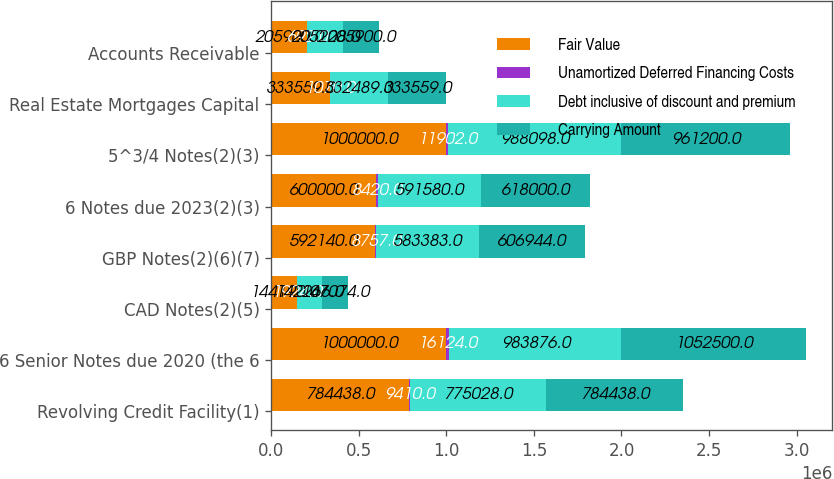<chart> <loc_0><loc_0><loc_500><loc_500><stacked_bar_chart><ecel><fcel>Revolving Credit Facility(1)<fcel>6 Senior Notes due 2020 (the 6<fcel>CAD Notes(2)(5)<fcel>GBP Notes(2)(6)(7)<fcel>6 Notes due 2023(2)(3)<fcel>5^3/4 Notes(2)(3)<fcel>Real Estate Mortgages Capital<fcel>Accounts Receivable<nl><fcel>Fair Value<fcel>784438<fcel>1e+06<fcel>144190<fcel>592140<fcel>600000<fcel>1e+06<fcel>333559<fcel>205900<nl><fcel>Unamortized Deferred Financing Costs<fcel>9410<fcel>16124<fcel>1924<fcel>8757<fcel>8420<fcel>11902<fcel>1070<fcel>692<nl><fcel>Debt inclusive of discount and premium<fcel>775028<fcel>983876<fcel>142266<fcel>583383<fcel>591580<fcel>988098<fcel>332489<fcel>205208<nl><fcel>Carrying Amount<fcel>784438<fcel>1.0525e+06<fcel>147074<fcel>606944<fcel>618000<fcel>961200<fcel>333559<fcel>205900<nl></chart> 